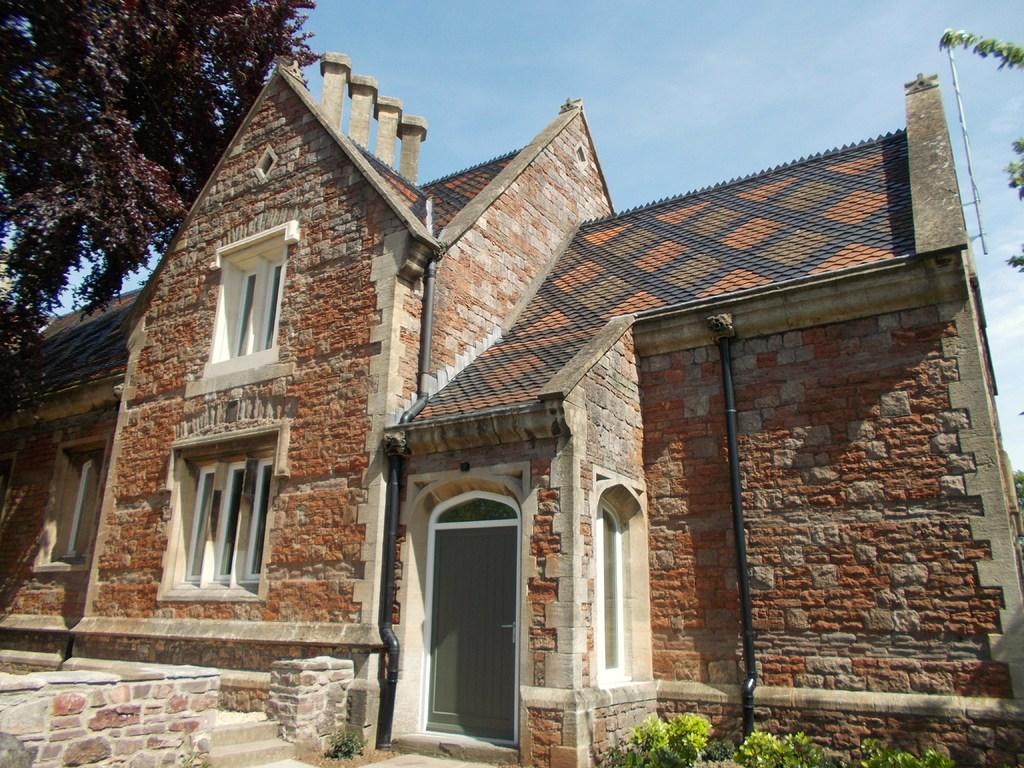Could you give a brief overview of what you see in this image? This image is taken outdoors. At the top of the image there is the sky with clouds. In the middle of the image there is a house with walls, windows, a roof, pillars and a door. There are two pipelines and there are two stairs. There are a few plants. On the left and right sides of the image there are a few trees with leaves, stems and branches. 